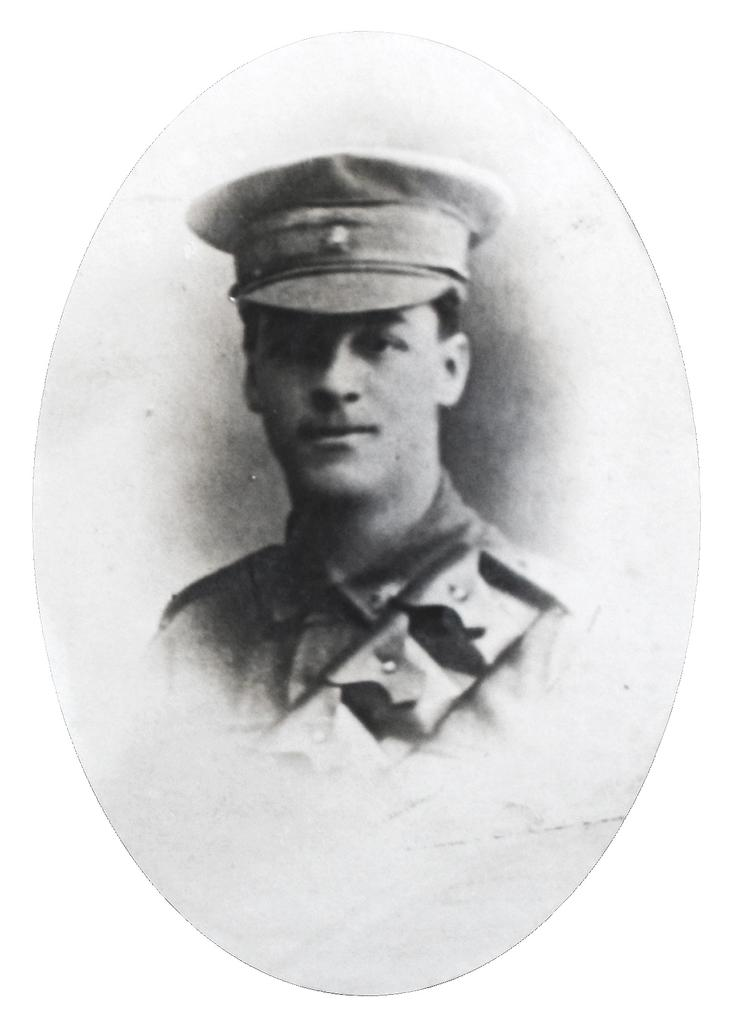What object is present in the image that typically holds a photograph? There is a photo frame in the image. What can be seen inside the photo frame? The photo frame contains an image of a policeman. What type of pollution is visible in the image? There is no pollution visible in the image; it only contains a photo frame with an image of a policeman. How many pears are present in the image? There are no pears present in the image. 